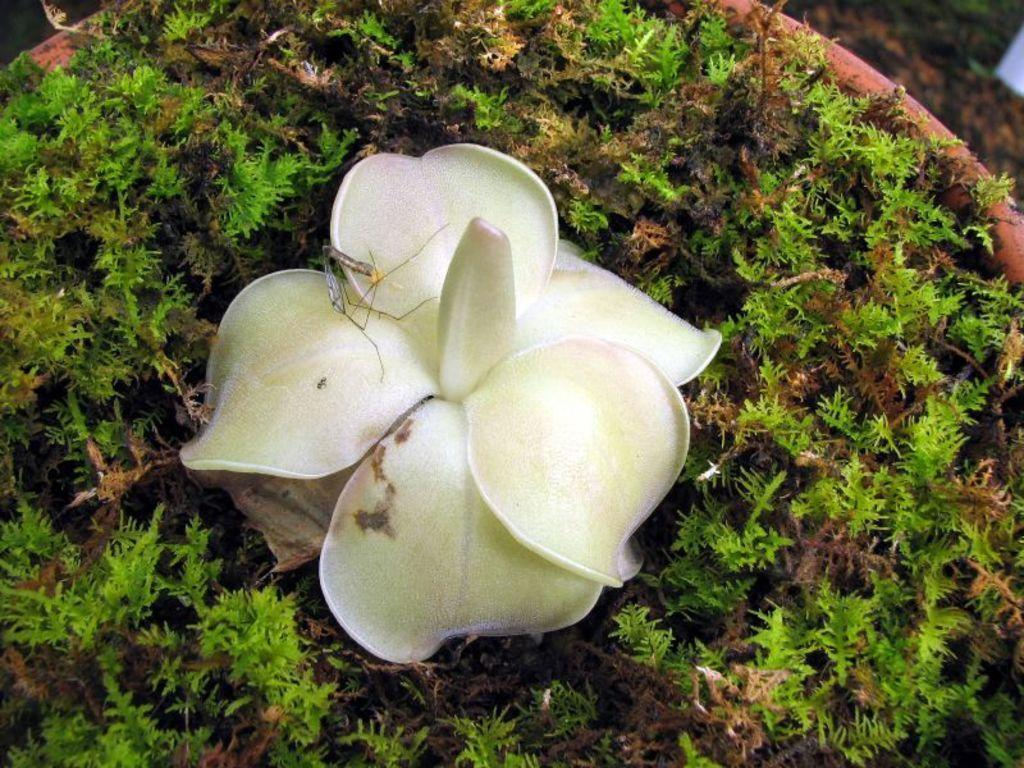What is present on the flower in the image? There is an insect on a flower in the image. What else can be seen in the image besides the insect and flower? Leaves are visible in the image. What is the chance of winning the lottery in the image? There is no reference to a lottery or any chances of winning in the image. 